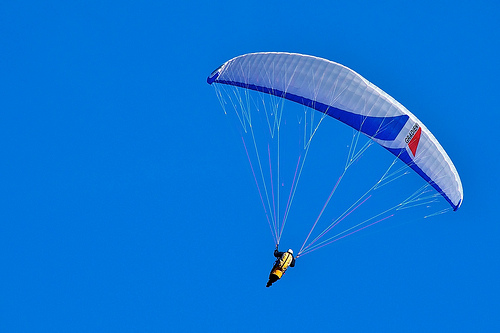Is the person wearing a helmet? Yes, the person is wearing a helmet for protection while flying. 